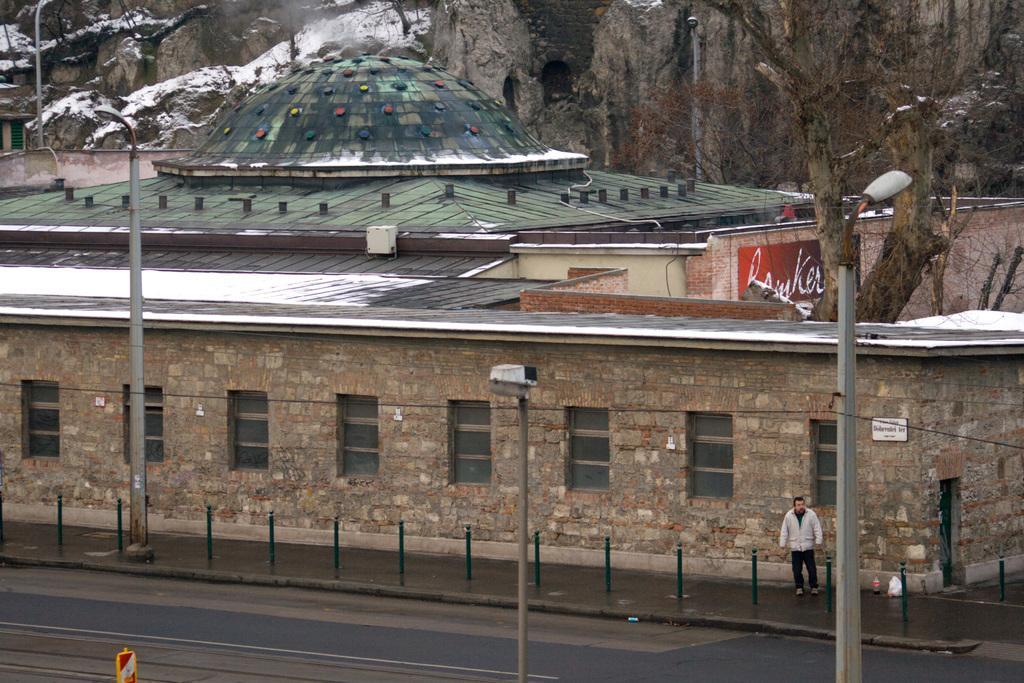How would you summarize this image in a sentence or two? This picture is clicked outside. In the foreground we can see the metal rods, lights and a person standing on the ground. In the center there is a building and we can see a dome on the top of the building and we can see the windows. In the background we can see the hills and the trunks of the trees. 